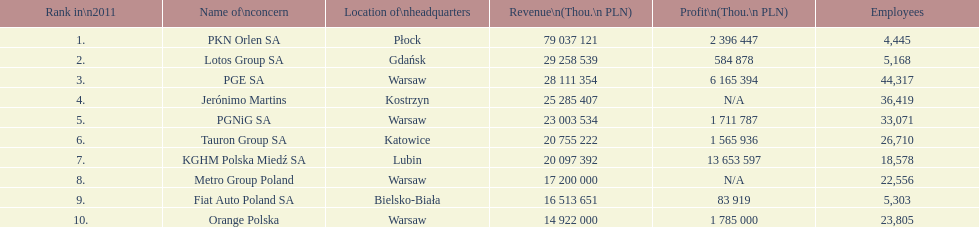Which organization has the greatest number of personnel? PGE SA. 